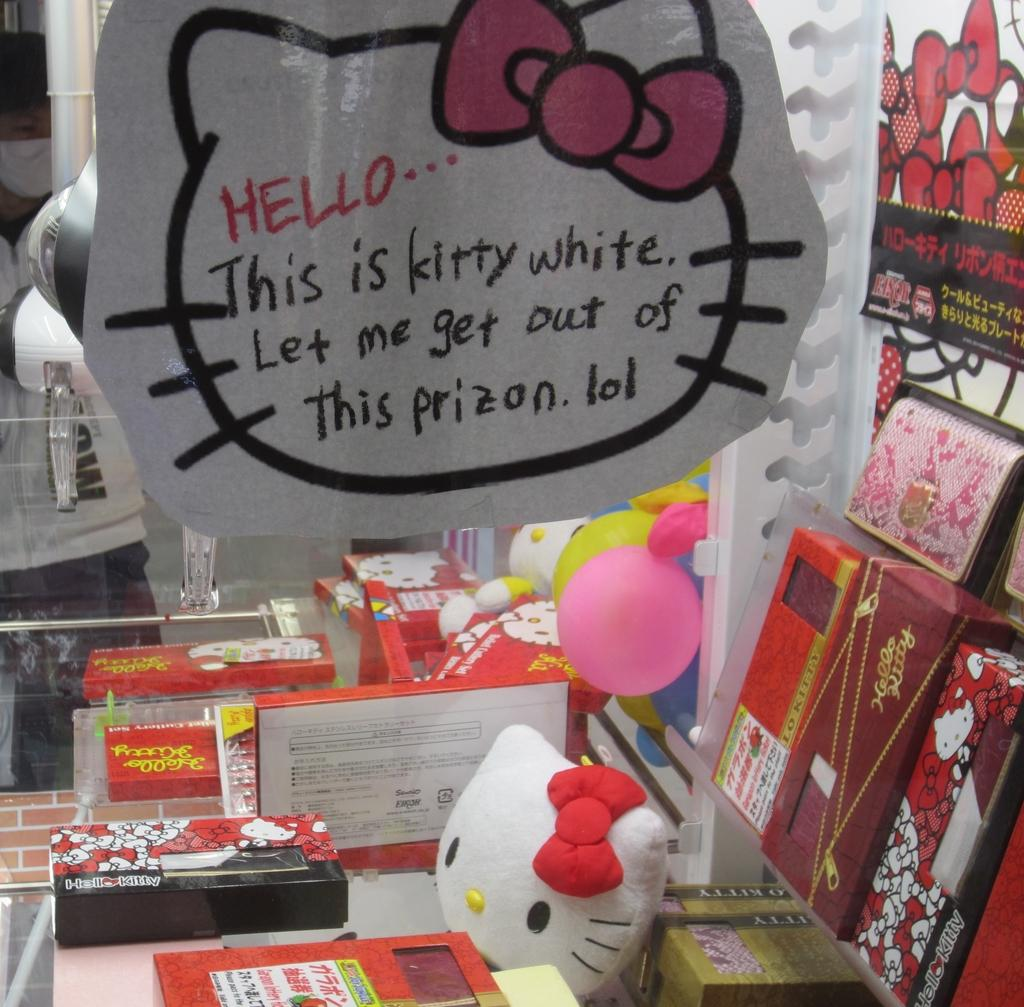Provide a one-sentence caption for the provided image. A variety of Hello Kitty products cover a small display area. 